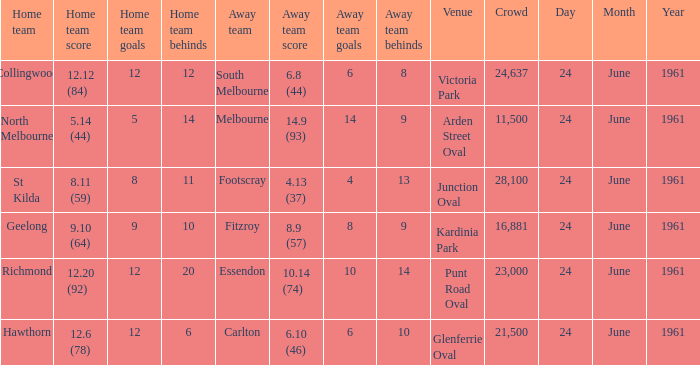Who was the home team that scored 12.6 (78)? Hawthorn. 